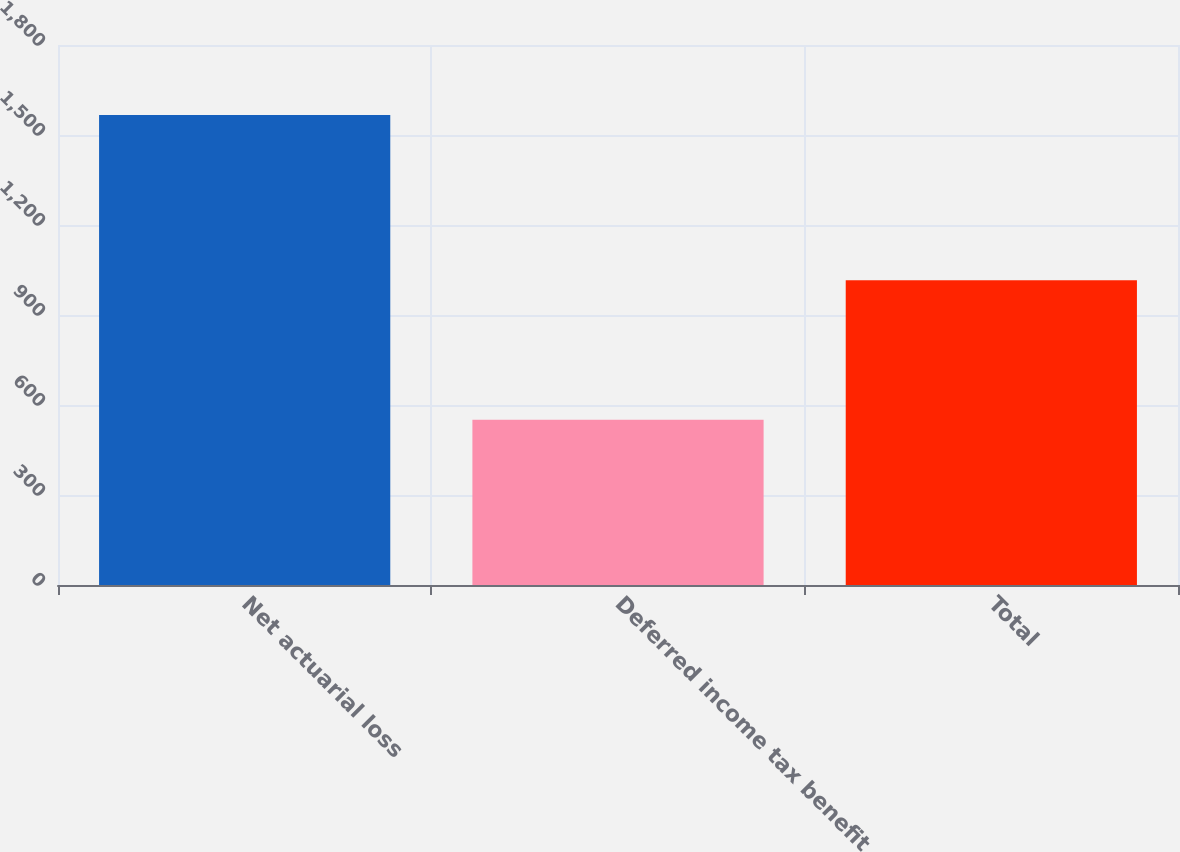Convert chart to OTSL. <chart><loc_0><loc_0><loc_500><loc_500><bar_chart><fcel>Net actuarial loss<fcel>Deferred income tax benefit<fcel>Total<nl><fcel>1567<fcel>551<fcel>1016<nl></chart> 